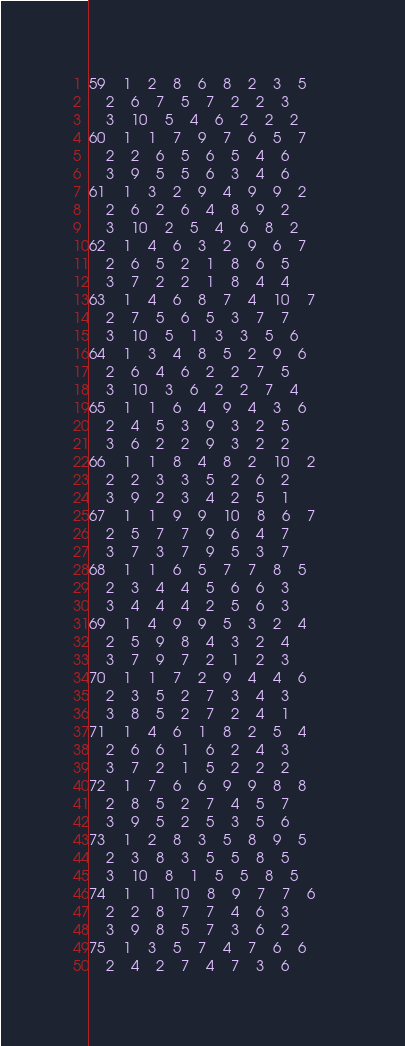Convert code to text. <code><loc_0><loc_0><loc_500><loc_500><_ObjectiveC_>59	1	2	8	6	8	2	3	5	
	2	6	7	5	7	2	2	3	
	3	10	5	4	6	2	2	2	
60	1	1	7	9	7	6	5	7	
	2	2	6	5	6	5	4	6	
	3	9	5	5	6	3	4	6	
61	1	3	2	9	4	9	9	2	
	2	6	2	6	4	8	9	2	
	3	10	2	5	4	6	8	2	
62	1	4	6	3	2	9	6	7	
	2	6	5	2	1	8	6	5	
	3	7	2	2	1	8	4	4	
63	1	4	6	8	7	4	10	7	
	2	7	5	6	5	3	7	7	
	3	10	5	1	3	3	5	6	
64	1	3	4	8	5	2	9	6	
	2	6	4	6	2	2	7	5	
	3	10	3	6	2	2	7	4	
65	1	1	6	4	9	4	3	6	
	2	4	5	3	9	3	2	5	
	3	6	2	2	9	3	2	2	
66	1	1	8	4	8	2	10	2	
	2	2	3	3	5	2	6	2	
	3	9	2	3	4	2	5	1	
67	1	1	9	9	10	8	6	7	
	2	5	7	7	9	6	4	7	
	3	7	3	7	9	5	3	7	
68	1	1	6	5	7	7	8	5	
	2	3	4	4	5	6	6	3	
	3	4	4	4	2	5	6	3	
69	1	4	9	9	5	3	2	4	
	2	5	9	8	4	3	2	4	
	3	7	9	7	2	1	2	3	
70	1	1	7	2	9	4	4	6	
	2	3	5	2	7	3	4	3	
	3	8	5	2	7	2	4	1	
71	1	4	6	1	8	2	5	4	
	2	6	6	1	6	2	4	3	
	3	7	2	1	5	2	2	2	
72	1	7	6	6	9	9	8	8	
	2	8	5	2	7	4	5	7	
	3	9	5	2	5	3	5	6	
73	1	2	8	3	5	8	9	5	
	2	3	8	3	5	5	8	5	
	3	10	8	1	5	5	8	5	
74	1	1	10	8	9	7	7	6	
	2	2	8	7	7	4	6	3	
	3	9	8	5	7	3	6	2	
75	1	3	5	7	4	7	6	6	
	2	4	2	7	4	7	3	6	</code> 